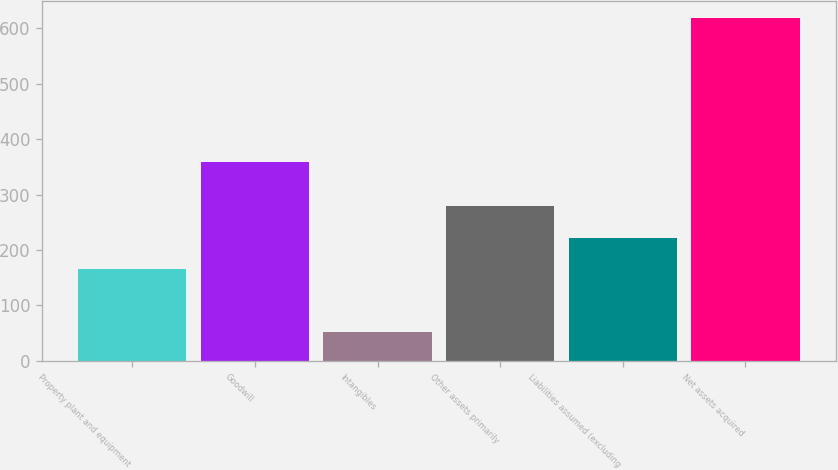<chart> <loc_0><loc_0><loc_500><loc_500><bar_chart><fcel>Property plant and equipment<fcel>Goodwill<fcel>Intangibles<fcel>Other assets primarily<fcel>Liabilities assumed (excluding<fcel>Net assets acquired<nl><fcel>165.7<fcel>358<fcel>51.9<fcel>278.9<fcel>222.3<fcel>617.9<nl></chart> 